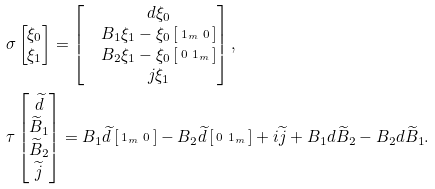<formula> <loc_0><loc_0><loc_500><loc_500>& \sigma \begin{bmatrix} \xi _ { 0 } \\ \xi _ { 1 } \end{bmatrix} = \begin{bmatrix} & d \xi _ { 0 } \\ & B _ { 1 } \xi _ { 1 } - \xi _ { 0 } \left [ \begin{smallmatrix} 1 _ { m } & 0 \end{smallmatrix} \right ] \\ & B _ { 2 } \xi _ { 1 } - \xi _ { 0 } \left [ \begin{smallmatrix} 0 & 1 _ { m } \end{smallmatrix} \right ] \\ & j \xi _ { 1 } \end{bmatrix} , \\ & \tau \begin{bmatrix} \widetilde { d } \\ \widetilde { B } _ { 1 } \\ \widetilde { B } _ { 2 } \\ \widetilde { j } \end{bmatrix} = B _ { 1 } \widetilde { d } \left [ \begin{smallmatrix} 1 _ { m } & 0 \end{smallmatrix} \right ] - B _ { 2 } \widetilde { d } \left [ \begin{smallmatrix} 0 & 1 _ { m } \end{smallmatrix} \right ] + i \widetilde { j } + B _ { 1 } d \widetilde { B } _ { 2 } - B _ { 2 } d \widetilde { B } _ { 1 } .</formula> 